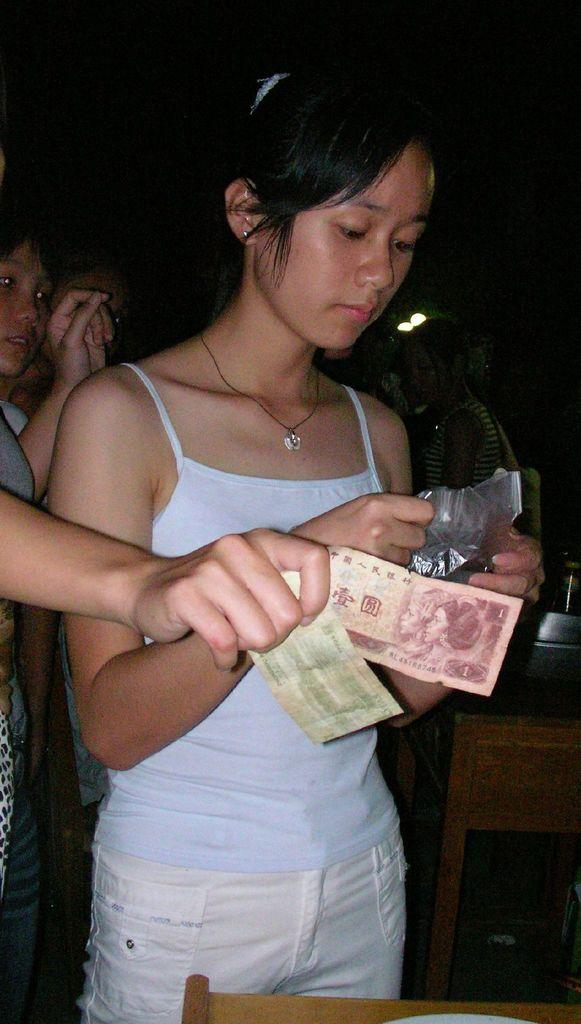What are the people in the image wearing? The persons in the image are wearing clothes. What is the person on the left side of the image holding? The person on the left side of the image is holding currency notes in their hand. What object can be seen in the bottom right of the image? There is a table in the bottom right of the image. What type of blood is visible on the person's clothes in the image? There is no blood visible on the person's clothes in the image. What kind of magic is being performed by the person on the right side of the image? There is no person on the right side of the image, and no magic is being performed. 